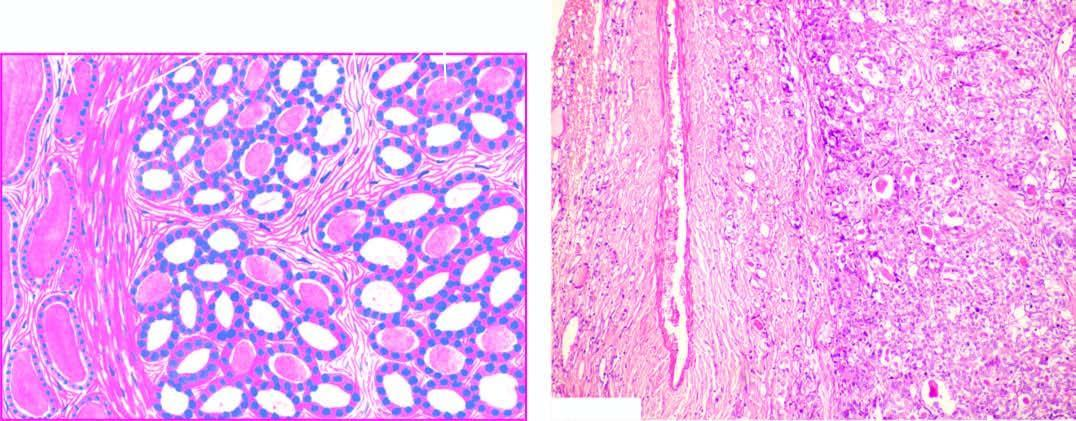what is well-encapsulated with compression of surrounding thyroid parenchyma?
Answer the question using a single word or phrase. Tumour 